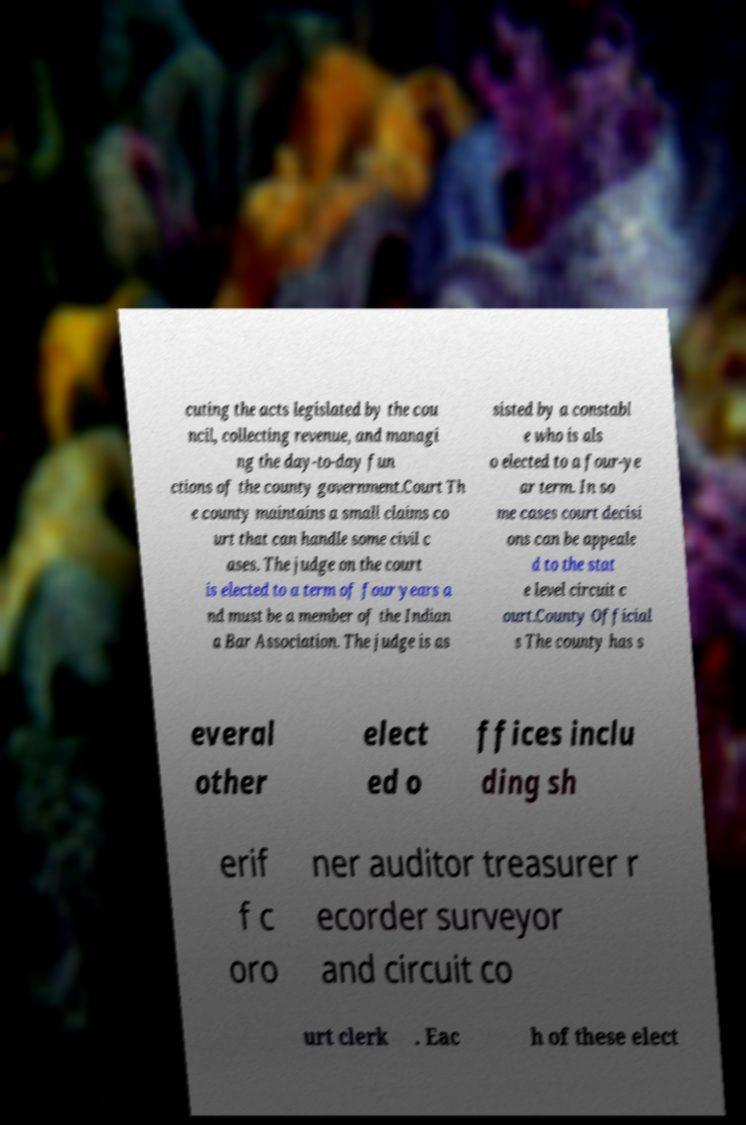Please identify and transcribe the text found in this image. cuting the acts legislated by the cou ncil, collecting revenue, and managi ng the day-to-day fun ctions of the county government.Court Th e county maintains a small claims co urt that can handle some civil c ases. The judge on the court is elected to a term of four years a nd must be a member of the Indian a Bar Association. The judge is as sisted by a constabl e who is als o elected to a four-ye ar term. In so me cases court decisi ons can be appeale d to the stat e level circuit c ourt.County Official s The county has s everal other elect ed o ffices inclu ding sh erif f c oro ner auditor treasurer r ecorder surveyor and circuit co urt clerk . Eac h of these elect 